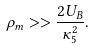Convert formula to latex. <formula><loc_0><loc_0><loc_500><loc_500>\rho _ { m } > > \frac { 2 U _ { B } } { \kappa _ { 5 } ^ { 2 } } .</formula> 